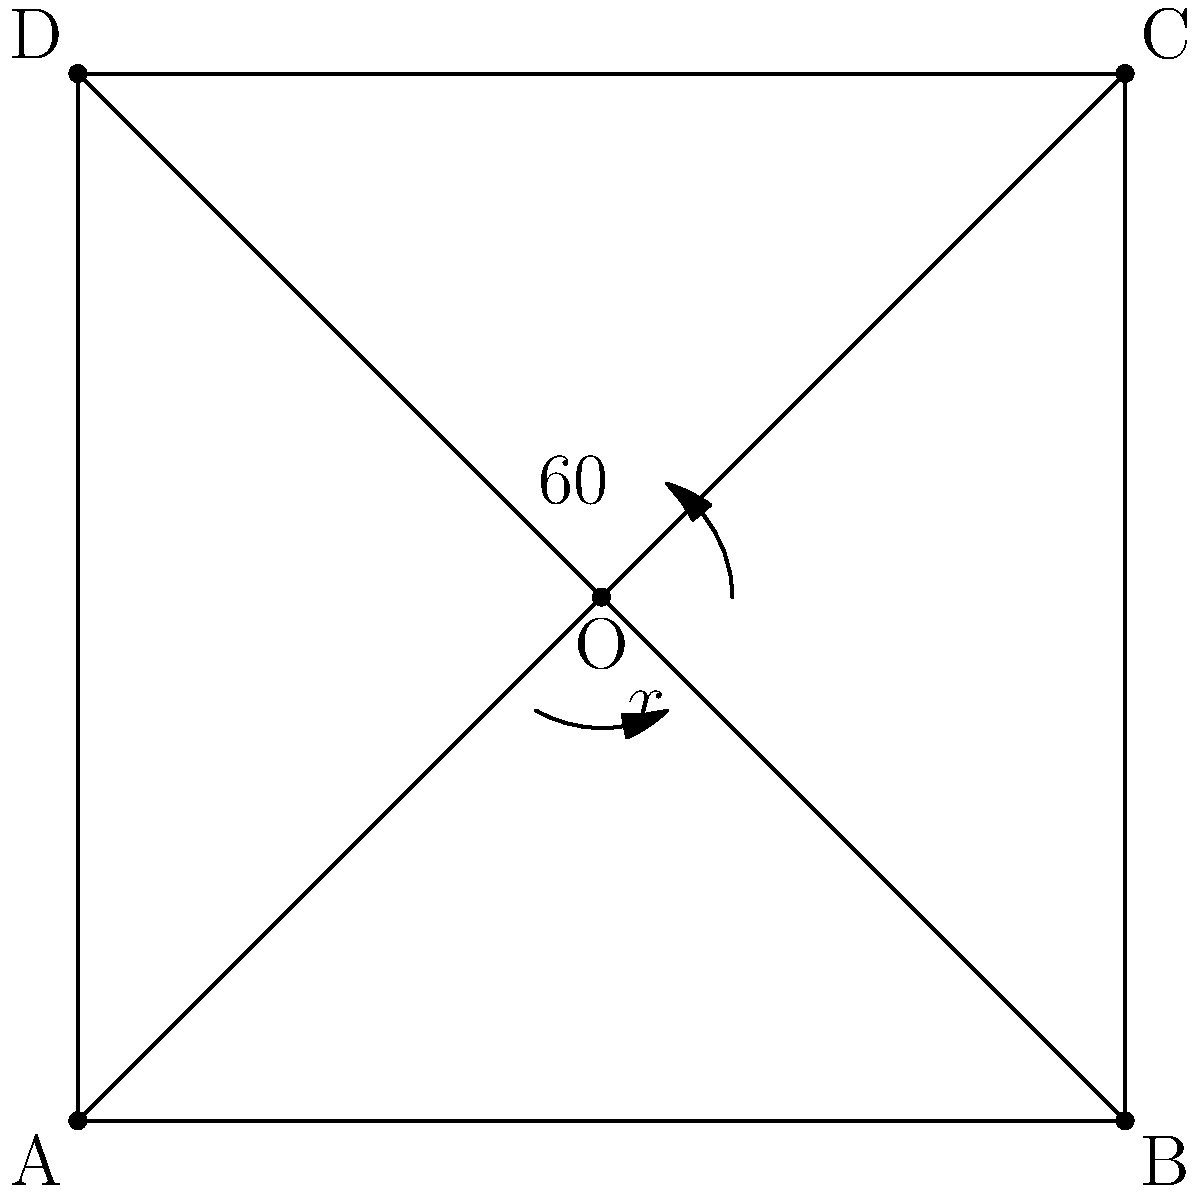At your local pub's dart board, you notice that the diagonal lines intersect at the center, forming four angles. If one of these angles measures 60°, what is the measure of the adjacent angle labeled $x°$? Let's approach this step-by-step:

1) In a dart board, the diagonal lines typically intersect at the center, forming four angles.

2) When two straight lines intersect, they form two pairs of vertical angles. Vertical angles are always congruent (equal in measure).

3) The sum of the measures of the angles around a point is always 360°.

4) Given that one angle is 60°, its vertical angle will also be 60°.

5) Let's call the measure of the unknown angle $x°$. Its vertical angle will also be $x°$.

6) We can set up an equation:
   
   $60° + 60° + x° + x° = 360°$

7) Simplify:
   
   $120° + 2x° = 360°$

8) Subtract 120° from both sides:
   
   $2x° = 240°$

9) Divide both sides by 2:
   
   $x° = 120°$

Therefore, the measure of the adjacent angle is 120°.
Answer: $120°$ 